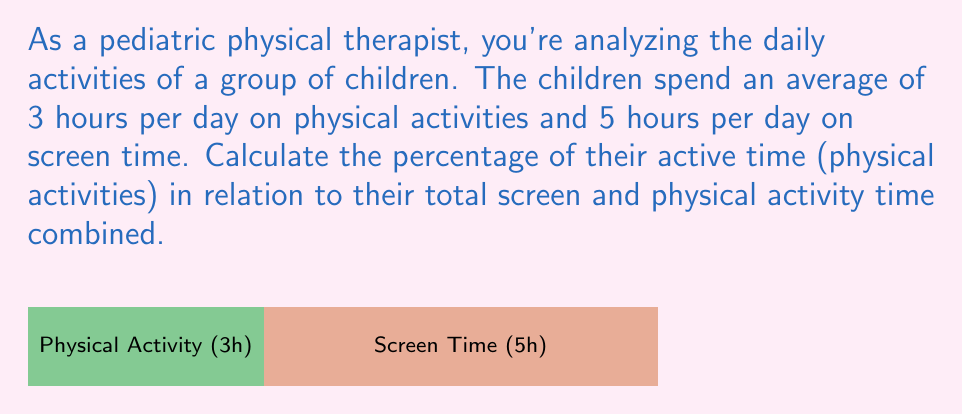Can you answer this question? Let's approach this step-by-step:

1) First, we need to calculate the total time spent on both activities:
   Total time = Physical activity time + Screen time
   $$ \text{Total time} = 3 \text{ hours} + 5 \text{ hours} = 8 \text{ hours} $$

2) Now, we want to find what percentage the physical activity time is of the total time.
   We can use the formula: $\text{Percentage} = \frac{\text{Part}}{\text{Whole}} \times 100\%$

3) In this case:
   Part = Physical activity time = 3 hours
   Whole = Total time = 8 hours

4) Let's plug these into our formula:
   $$ \text{Percentage} = \frac{3}{8} \times 100\% $$

5) Simplify:
   $$ \text{Percentage} = 0.375 \times 100\% = 37.5\% $$

Therefore, the physical activity time represents 37.5% of the total screen and physical activity time combined.
Answer: 37.5% 